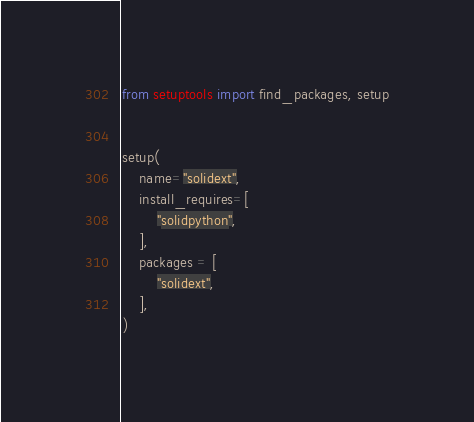<code> <loc_0><loc_0><loc_500><loc_500><_Python_>from setuptools import find_packages, setup


setup(
    name="solidext",
    install_requires=[
        "solidpython",
    ],
    packages = [
        "solidext",
    ],
)
</code> 